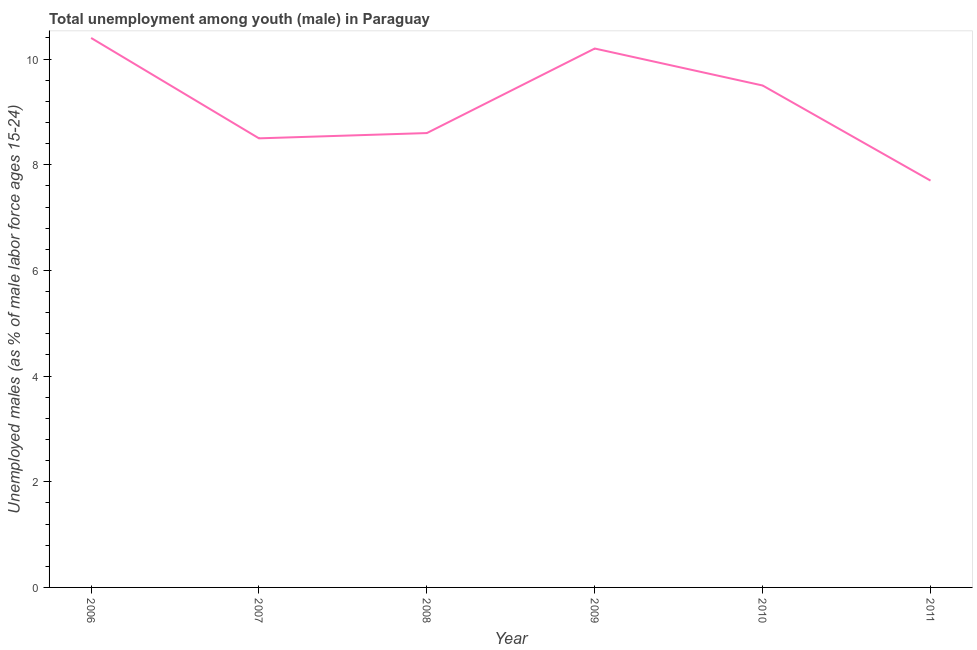What is the unemployed male youth population in 2009?
Give a very brief answer. 10.2. Across all years, what is the maximum unemployed male youth population?
Offer a terse response. 10.4. Across all years, what is the minimum unemployed male youth population?
Offer a terse response. 7.7. In which year was the unemployed male youth population maximum?
Offer a very short reply. 2006. What is the sum of the unemployed male youth population?
Ensure brevity in your answer.  54.9. What is the difference between the unemployed male youth population in 2008 and 2009?
Give a very brief answer. -1.6. What is the average unemployed male youth population per year?
Ensure brevity in your answer.  9.15. What is the median unemployed male youth population?
Provide a succinct answer. 9.05. What is the ratio of the unemployed male youth population in 2009 to that in 2010?
Provide a short and direct response. 1.07. Is the unemployed male youth population in 2006 less than that in 2010?
Offer a very short reply. No. Is the difference between the unemployed male youth population in 2008 and 2009 greater than the difference between any two years?
Give a very brief answer. No. What is the difference between the highest and the second highest unemployed male youth population?
Your answer should be compact. 0.2. What is the difference between the highest and the lowest unemployed male youth population?
Give a very brief answer. 2.7. How many lines are there?
Your answer should be compact. 1. What is the difference between two consecutive major ticks on the Y-axis?
Your answer should be compact. 2. Does the graph contain any zero values?
Provide a short and direct response. No. Does the graph contain grids?
Give a very brief answer. No. What is the title of the graph?
Keep it short and to the point. Total unemployment among youth (male) in Paraguay. What is the label or title of the Y-axis?
Ensure brevity in your answer.  Unemployed males (as % of male labor force ages 15-24). What is the Unemployed males (as % of male labor force ages 15-24) in 2006?
Your answer should be very brief. 10.4. What is the Unemployed males (as % of male labor force ages 15-24) in 2008?
Provide a succinct answer. 8.6. What is the Unemployed males (as % of male labor force ages 15-24) in 2009?
Keep it short and to the point. 10.2. What is the Unemployed males (as % of male labor force ages 15-24) of 2011?
Your answer should be very brief. 7.7. What is the difference between the Unemployed males (as % of male labor force ages 15-24) in 2006 and 2007?
Provide a short and direct response. 1.9. What is the difference between the Unemployed males (as % of male labor force ages 15-24) in 2006 and 2008?
Your answer should be compact. 1.8. What is the difference between the Unemployed males (as % of male labor force ages 15-24) in 2006 and 2010?
Your answer should be compact. 0.9. What is the difference between the Unemployed males (as % of male labor force ages 15-24) in 2006 and 2011?
Make the answer very short. 2.7. What is the difference between the Unemployed males (as % of male labor force ages 15-24) in 2007 and 2008?
Your answer should be compact. -0.1. What is the difference between the Unemployed males (as % of male labor force ages 15-24) in 2008 and 2009?
Your response must be concise. -1.6. What is the difference between the Unemployed males (as % of male labor force ages 15-24) in 2008 and 2010?
Provide a succinct answer. -0.9. What is the difference between the Unemployed males (as % of male labor force ages 15-24) in 2008 and 2011?
Your response must be concise. 0.9. What is the difference between the Unemployed males (as % of male labor force ages 15-24) in 2009 and 2010?
Your answer should be very brief. 0.7. What is the ratio of the Unemployed males (as % of male labor force ages 15-24) in 2006 to that in 2007?
Give a very brief answer. 1.22. What is the ratio of the Unemployed males (as % of male labor force ages 15-24) in 2006 to that in 2008?
Make the answer very short. 1.21. What is the ratio of the Unemployed males (as % of male labor force ages 15-24) in 2006 to that in 2010?
Make the answer very short. 1.09. What is the ratio of the Unemployed males (as % of male labor force ages 15-24) in 2006 to that in 2011?
Provide a succinct answer. 1.35. What is the ratio of the Unemployed males (as % of male labor force ages 15-24) in 2007 to that in 2009?
Keep it short and to the point. 0.83. What is the ratio of the Unemployed males (as % of male labor force ages 15-24) in 2007 to that in 2010?
Give a very brief answer. 0.9. What is the ratio of the Unemployed males (as % of male labor force ages 15-24) in 2007 to that in 2011?
Provide a short and direct response. 1.1. What is the ratio of the Unemployed males (as % of male labor force ages 15-24) in 2008 to that in 2009?
Make the answer very short. 0.84. What is the ratio of the Unemployed males (as % of male labor force ages 15-24) in 2008 to that in 2010?
Give a very brief answer. 0.91. What is the ratio of the Unemployed males (as % of male labor force ages 15-24) in 2008 to that in 2011?
Provide a short and direct response. 1.12. What is the ratio of the Unemployed males (as % of male labor force ages 15-24) in 2009 to that in 2010?
Your answer should be compact. 1.07. What is the ratio of the Unemployed males (as % of male labor force ages 15-24) in 2009 to that in 2011?
Make the answer very short. 1.32. What is the ratio of the Unemployed males (as % of male labor force ages 15-24) in 2010 to that in 2011?
Provide a succinct answer. 1.23. 